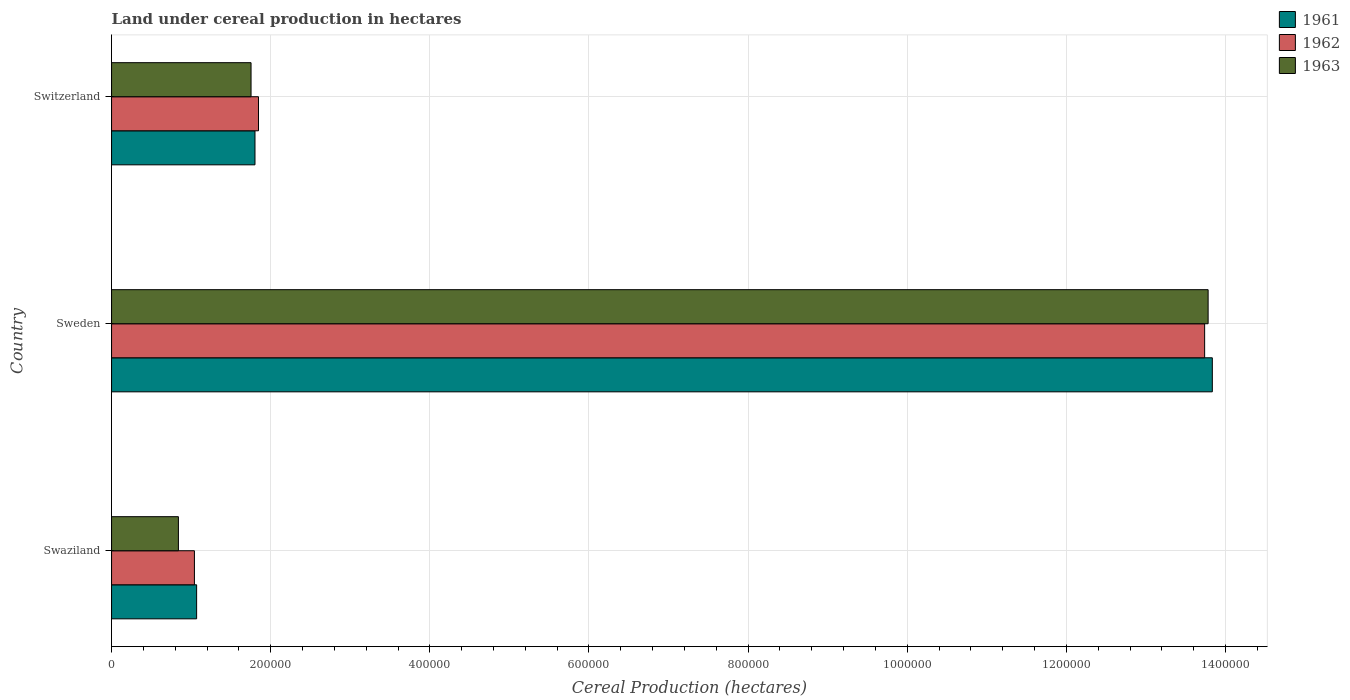How many groups of bars are there?
Provide a short and direct response. 3. Are the number of bars per tick equal to the number of legend labels?
Your response must be concise. Yes. Are the number of bars on each tick of the Y-axis equal?
Offer a terse response. Yes. How many bars are there on the 1st tick from the top?
Ensure brevity in your answer.  3. What is the label of the 2nd group of bars from the top?
Your answer should be very brief. Sweden. In how many cases, is the number of bars for a given country not equal to the number of legend labels?
Your response must be concise. 0. What is the land under cereal production in 1962 in Sweden?
Give a very brief answer. 1.37e+06. Across all countries, what is the maximum land under cereal production in 1961?
Your answer should be very brief. 1.38e+06. Across all countries, what is the minimum land under cereal production in 1961?
Offer a very short reply. 1.07e+05. In which country was the land under cereal production in 1961 minimum?
Ensure brevity in your answer.  Swaziland. What is the total land under cereal production in 1963 in the graph?
Your response must be concise. 1.64e+06. What is the difference between the land under cereal production in 1963 in Sweden and that in Switzerland?
Make the answer very short. 1.20e+06. What is the difference between the land under cereal production in 1962 in Swaziland and the land under cereal production in 1961 in Sweden?
Provide a succinct answer. -1.28e+06. What is the average land under cereal production in 1961 per country?
Provide a short and direct response. 5.57e+05. What is the difference between the land under cereal production in 1963 and land under cereal production in 1962 in Swaziland?
Make the answer very short. -2.01e+04. What is the ratio of the land under cereal production in 1962 in Swaziland to that in Switzerland?
Your answer should be very brief. 0.56. Is the land under cereal production in 1963 in Swaziland less than that in Sweden?
Keep it short and to the point. Yes. Is the difference between the land under cereal production in 1963 in Sweden and Switzerland greater than the difference between the land under cereal production in 1962 in Sweden and Switzerland?
Offer a terse response. Yes. What is the difference between the highest and the second highest land under cereal production in 1963?
Offer a very short reply. 1.20e+06. What is the difference between the highest and the lowest land under cereal production in 1963?
Offer a very short reply. 1.29e+06. What does the 1st bar from the top in Sweden represents?
Give a very brief answer. 1963. What does the 2nd bar from the bottom in Swaziland represents?
Your answer should be very brief. 1962. Is it the case that in every country, the sum of the land under cereal production in 1963 and land under cereal production in 1962 is greater than the land under cereal production in 1961?
Make the answer very short. Yes. How many countries are there in the graph?
Offer a terse response. 3. What is the difference between two consecutive major ticks on the X-axis?
Give a very brief answer. 2.00e+05. Are the values on the major ticks of X-axis written in scientific E-notation?
Give a very brief answer. No. Does the graph contain any zero values?
Make the answer very short. No. Where does the legend appear in the graph?
Your answer should be compact. Top right. What is the title of the graph?
Make the answer very short. Land under cereal production in hectares. Does "1979" appear as one of the legend labels in the graph?
Your answer should be compact. No. What is the label or title of the X-axis?
Give a very brief answer. Cereal Production (hectares). What is the label or title of the Y-axis?
Give a very brief answer. Country. What is the Cereal Production (hectares) of 1961 in Swaziland?
Ensure brevity in your answer.  1.07e+05. What is the Cereal Production (hectares) in 1962 in Swaziland?
Provide a succinct answer. 1.04e+05. What is the Cereal Production (hectares) of 1963 in Swaziland?
Provide a succinct answer. 8.40e+04. What is the Cereal Production (hectares) in 1961 in Sweden?
Your response must be concise. 1.38e+06. What is the Cereal Production (hectares) of 1962 in Sweden?
Provide a short and direct response. 1.37e+06. What is the Cereal Production (hectares) of 1963 in Sweden?
Your response must be concise. 1.38e+06. What is the Cereal Production (hectares) in 1961 in Switzerland?
Provide a short and direct response. 1.80e+05. What is the Cereal Production (hectares) in 1962 in Switzerland?
Give a very brief answer. 1.85e+05. What is the Cereal Production (hectares) in 1963 in Switzerland?
Your response must be concise. 1.75e+05. Across all countries, what is the maximum Cereal Production (hectares) of 1961?
Ensure brevity in your answer.  1.38e+06. Across all countries, what is the maximum Cereal Production (hectares) of 1962?
Your answer should be very brief. 1.37e+06. Across all countries, what is the maximum Cereal Production (hectares) in 1963?
Offer a very short reply. 1.38e+06. Across all countries, what is the minimum Cereal Production (hectares) of 1961?
Provide a succinct answer. 1.07e+05. Across all countries, what is the minimum Cereal Production (hectares) in 1962?
Offer a terse response. 1.04e+05. Across all countries, what is the minimum Cereal Production (hectares) of 1963?
Your answer should be very brief. 8.40e+04. What is the total Cereal Production (hectares) in 1961 in the graph?
Ensure brevity in your answer.  1.67e+06. What is the total Cereal Production (hectares) in 1962 in the graph?
Make the answer very short. 1.66e+06. What is the total Cereal Production (hectares) in 1963 in the graph?
Offer a terse response. 1.64e+06. What is the difference between the Cereal Production (hectares) of 1961 in Swaziland and that in Sweden?
Ensure brevity in your answer.  -1.28e+06. What is the difference between the Cereal Production (hectares) of 1962 in Swaziland and that in Sweden?
Ensure brevity in your answer.  -1.27e+06. What is the difference between the Cereal Production (hectares) of 1963 in Swaziland and that in Sweden?
Make the answer very short. -1.29e+06. What is the difference between the Cereal Production (hectares) of 1961 in Swaziland and that in Switzerland?
Keep it short and to the point. -7.34e+04. What is the difference between the Cereal Production (hectares) of 1962 in Swaziland and that in Switzerland?
Make the answer very short. -8.05e+04. What is the difference between the Cereal Production (hectares) of 1963 in Swaziland and that in Switzerland?
Ensure brevity in your answer.  -9.13e+04. What is the difference between the Cereal Production (hectares) in 1961 in Sweden and that in Switzerland?
Offer a very short reply. 1.20e+06. What is the difference between the Cereal Production (hectares) in 1962 in Sweden and that in Switzerland?
Provide a short and direct response. 1.19e+06. What is the difference between the Cereal Production (hectares) of 1963 in Sweden and that in Switzerland?
Offer a very short reply. 1.20e+06. What is the difference between the Cereal Production (hectares) of 1961 in Swaziland and the Cereal Production (hectares) of 1962 in Sweden?
Offer a terse response. -1.27e+06. What is the difference between the Cereal Production (hectares) in 1961 in Swaziland and the Cereal Production (hectares) in 1963 in Sweden?
Offer a terse response. -1.27e+06. What is the difference between the Cereal Production (hectares) in 1962 in Swaziland and the Cereal Production (hectares) in 1963 in Sweden?
Ensure brevity in your answer.  -1.27e+06. What is the difference between the Cereal Production (hectares) in 1961 in Swaziland and the Cereal Production (hectares) in 1962 in Switzerland?
Make the answer very short. -7.77e+04. What is the difference between the Cereal Production (hectares) in 1961 in Swaziland and the Cereal Production (hectares) in 1963 in Switzerland?
Your response must be concise. -6.84e+04. What is the difference between the Cereal Production (hectares) of 1962 in Swaziland and the Cereal Production (hectares) of 1963 in Switzerland?
Offer a terse response. -7.12e+04. What is the difference between the Cereal Production (hectares) in 1961 in Sweden and the Cereal Production (hectares) in 1962 in Switzerland?
Ensure brevity in your answer.  1.20e+06. What is the difference between the Cereal Production (hectares) in 1961 in Sweden and the Cereal Production (hectares) in 1963 in Switzerland?
Your response must be concise. 1.21e+06. What is the difference between the Cereal Production (hectares) in 1962 in Sweden and the Cereal Production (hectares) in 1963 in Switzerland?
Your answer should be compact. 1.20e+06. What is the average Cereal Production (hectares) of 1961 per country?
Your response must be concise. 5.57e+05. What is the average Cereal Production (hectares) in 1962 per country?
Ensure brevity in your answer.  5.54e+05. What is the average Cereal Production (hectares) in 1963 per country?
Provide a short and direct response. 5.46e+05. What is the difference between the Cereal Production (hectares) in 1961 and Cereal Production (hectares) in 1962 in Swaziland?
Ensure brevity in your answer.  2763. What is the difference between the Cereal Production (hectares) in 1961 and Cereal Production (hectares) in 1963 in Swaziland?
Your answer should be very brief. 2.29e+04. What is the difference between the Cereal Production (hectares) in 1962 and Cereal Production (hectares) in 1963 in Swaziland?
Your answer should be compact. 2.01e+04. What is the difference between the Cereal Production (hectares) in 1961 and Cereal Production (hectares) in 1962 in Sweden?
Make the answer very short. 9669. What is the difference between the Cereal Production (hectares) in 1961 and Cereal Production (hectares) in 1963 in Sweden?
Offer a terse response. 5292. What is the difference between the Cereal Production (hectares) of 1962 and Cereal Production (hectares) of 1963 in Sweden?
Provide a short and direct response. -4377. What is the difference between the Cereal Production (hectares) of 1961 and Cereal Production (hectares) of 1962 in Switzerland?
Keep it short and to the point. -4395. What is the difference between the Cereal Production (hectares) in 1961 and Cereal Production (hectares) in 1963 in Switzerland?
Offer a very short reply. 4955. What is the difference between the Cereal Production (hectares) in 1962 and Cereal Production (hectares) in 1963 in Switzerland?
Your answer should be very brief. 9350. What is the ratio of the Cereal Production (hectares) in 1961 in Swaziland to that in Sweden?
Offer a very short reply. 0.08. What is the ratio of the Cereal Production (hectares) in 1962 in Swaziland to that in Sweden?
Ensure brevity in your answer.  0.08. What is the ratio of the Cereal Production (hectares) in 1963 in Swaziland to that in Sweden?
Ensure brevity in your answer.  0.06. What is the ratio of the Cereal Production (hectares) of 1961 in Swaziland to that in Switzerland?
Give a very brief answer. 0.59. What is the ratio of the Cereal Production (hectares) in 1962 in Swaziland to that in Switzerland?
Your answer should be very brief. 0.56. What is the ratio of the Cereal Production (hectares) in 1963 in Swaziland to that in Switzerland?
Make the answer very short. 0.48. What is the ratio of the Cereal Production (hectares) in 1961 in Sweden to that in Switzerland?
Give a very brief answer. 7.67. What is the ratio of the Cereal Production (hectares) of 1962 in Sweden to that in Switzerland?
Offer a very short reply. 7.44. What is the ratio of the Cereal Production (hectares) of 1963 in Sweden to that in Switzerland?
Your answer should be compact. 7.86. What is the difference between the highest and the second highest Cereal Production (hectares) of 1961?
Ensure brevity in your answer.  1.20e+06. What is the difference between the highest and the second highest Cereal Production (hectares) in 1962?
Your response must be concise. 1.19e+06. What is the difference between the highest and the second highest Cereal Production (hectares) in 1963?
Your answer should be very brief. 1.20e+06. What is the difference between the highest and the lowest Cereal Production (hectares) in 1961?
Your response must be concise. 1.28e+06. What is the difference between the highest and the lowest Cereal Production (hectares) in 1962?
Ensure brevity in your answer.  1.27e+06. What is the difference between the highest and the lowest Cereal Production (hectares) in 1963?
Offer a very short reply. 1.29e+06. 